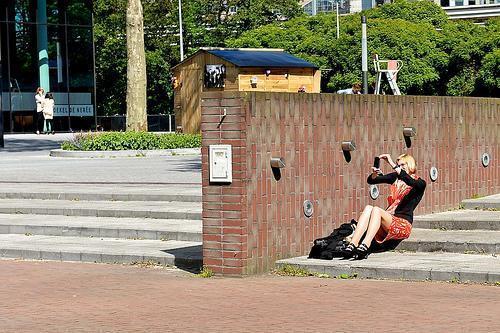How many people are in the photo?
Give a very brief answer. 4. 